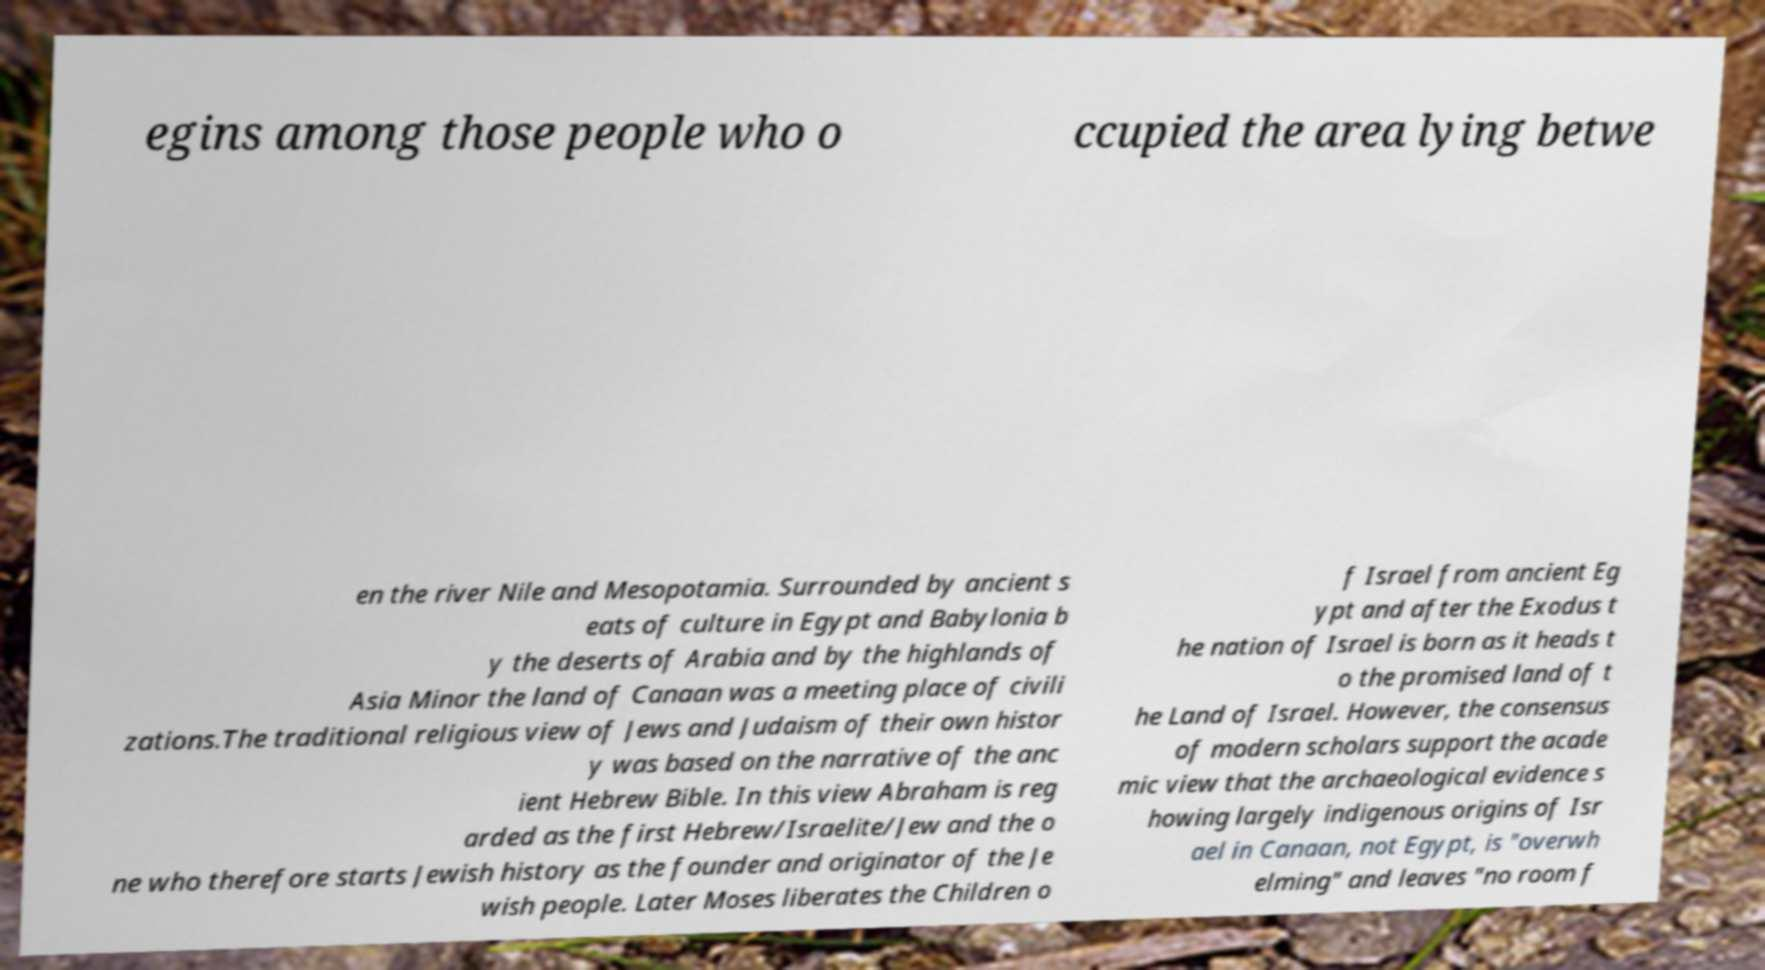Please read and relay the text visible in this image. What does it say? egins among those people who o ccupied the area lying betwe en the river Nile and Mesopotamia. Surrounded by ancient s eats of culture in Egypt and Babylonia b y the deserts of Arabia and by the highlands of Asia Minor the land of Canaan was a meeting place of civili zations.The traditional religious view of Jews and Judaism of their own histor y was based on the narrative of the anc ient Hebrew Bible. In this view Abraham is reg arded as the first Hebrew/Israelite/Jew and the o ne who therefore starts Jewish history as the founder and originator of the Je wish people. Later Moses liberates the Children o f Israel from ancient Eg ypt and after the Exodus t he nation of Israel is born as it heads t o the promised land of t he Land of Israel. However, the consensus of modern scholars support the acade mic view that the archaeological evidence s howing largely indigenous origins of Isr ael in Canaan, not Egypt, is "overwh elming" and leaves "no room f 